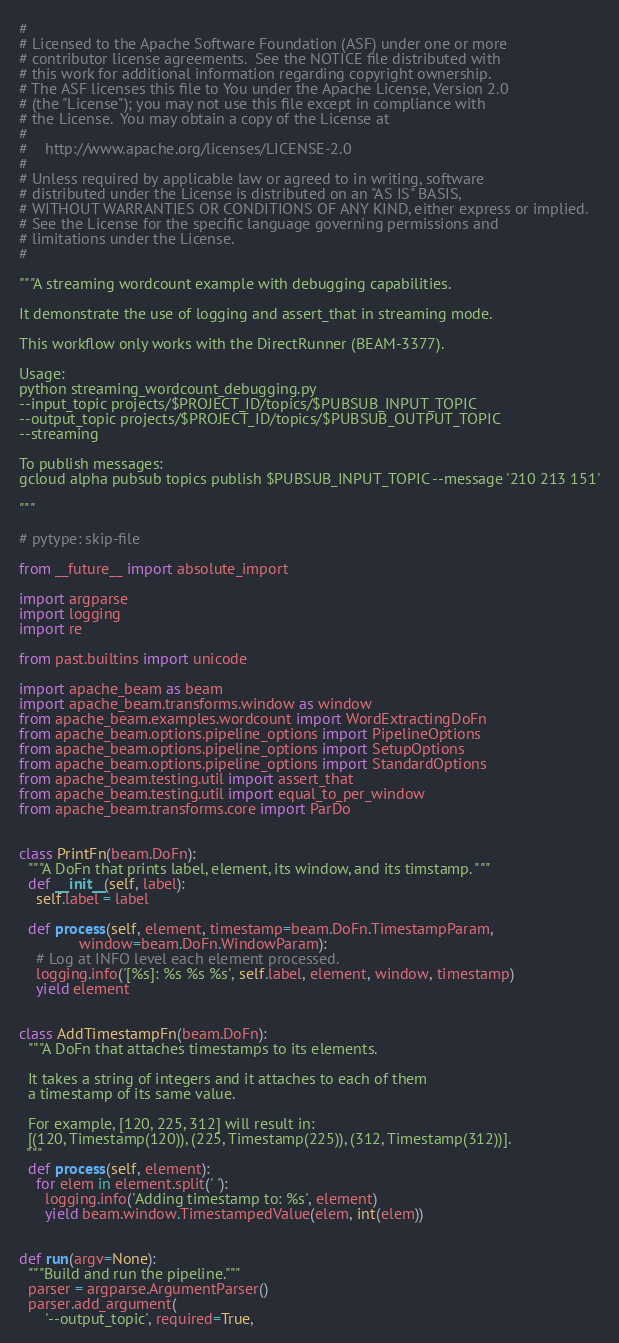Convert code to text. <code><loc_0><loc_0><loc_500><loc_500><_Python_>#
# Licensed to the Apache Software Foundation (ASF) under one or more
# contributor license agreements.  See the NOTICE file distributed with
# this work for additional information regarding copyright ownership.
# The ASF licenses this file to You under the Apache License, Version 2.0
# (the "License"); you may not use this file except in compliance with
# the License.  You may obtain a copy of the License at
#
#    http://www.apache.org/licenses/LICENSE-2.0
#
# Unless required by applicable law or agreed to in writing, software
# distributed under the License is distributed on an "AS IS" BASIS,
# WITHOUT WARRANTIES OR CONDITIONS OF ANY KIND, either express or implied.
# See the License for the specific language governing permissions and
# limitations under the License.
#

"""A streaming wordcount example with debugging capabilities.

It demonstrate the use of logging and assert_that in streaming mode.

This workflow only works with the DirectRunner (BEAM-3377).

Usage:
python streaming_wordcount_debugging.py
--input_topic projects/$PROJECT_ID/topics/$PUBSUB_INPUT_TOPIC
--output_topic projects/$PROJECT_ID/topics/$PUBSUB_OUTPUT_TOPIC
--streaming

To publish messages:
gcloud alpha pubsub topics publish $PUBSUB_INPUT_TOPIC --message '210 213 151'

"""

# pytype: skip-file

from __future__ import absolute_import

import argparse
import logging
import re

from past.builtins import unicode

import apache_beam as beam
import apache_beam.transforms.window as window
from apache_beam.examples.wordcount import WordExtractingDoFn
from apache_beam.options.pipeline_options import PipelineOptions
from apache_beam.options.pipeline_options import SetupOptions
from apache_beam.options.pipeline_options import StandardOptions
from apache_beam.testing.util import assert_that
from apache_beam.testing.util import equal_to_per_window
from apache_beam.transforms.core import ParDo


class PrintFn(beam.DoFn):
  """A DoFn that prints label, element, its window, and its timstamp. """
  def __init__(self, label):
    self.label = label

  def process(self, element, timestamp=beam.DoFn.TimestampParam,
              window=beam.DoFn.WindowParam):
    # Log at INFO level each element processed.
    logging.info('[%s]: %s %s %s', self.label, element, window, timestamp)
    yield element


class AddTimestampFn(beam.DoFn):
  """A DoFn that attaches timestamps to its elements.

  It takes a string of integers and it attaches to each of them
  a timestamp of its same value.

  For example, [120, 225, 312] will result in:
  [(120, Timestamp(120)), (225, Timestamp(225)), (312, Timestamp(312))].
  """
  def process(self, element):
    for elem in element.split(' '):
      logging.info('Adding timestamp to: %s', element)
      yield beam.window.TimestampedValue(elem, int(elem))


def run(argv=None):
  """Build and run the pipeline."""
  parser = argparse.ArgumentParser()
  parser.add_argument(
      '--output_topic', required=True,</code> 